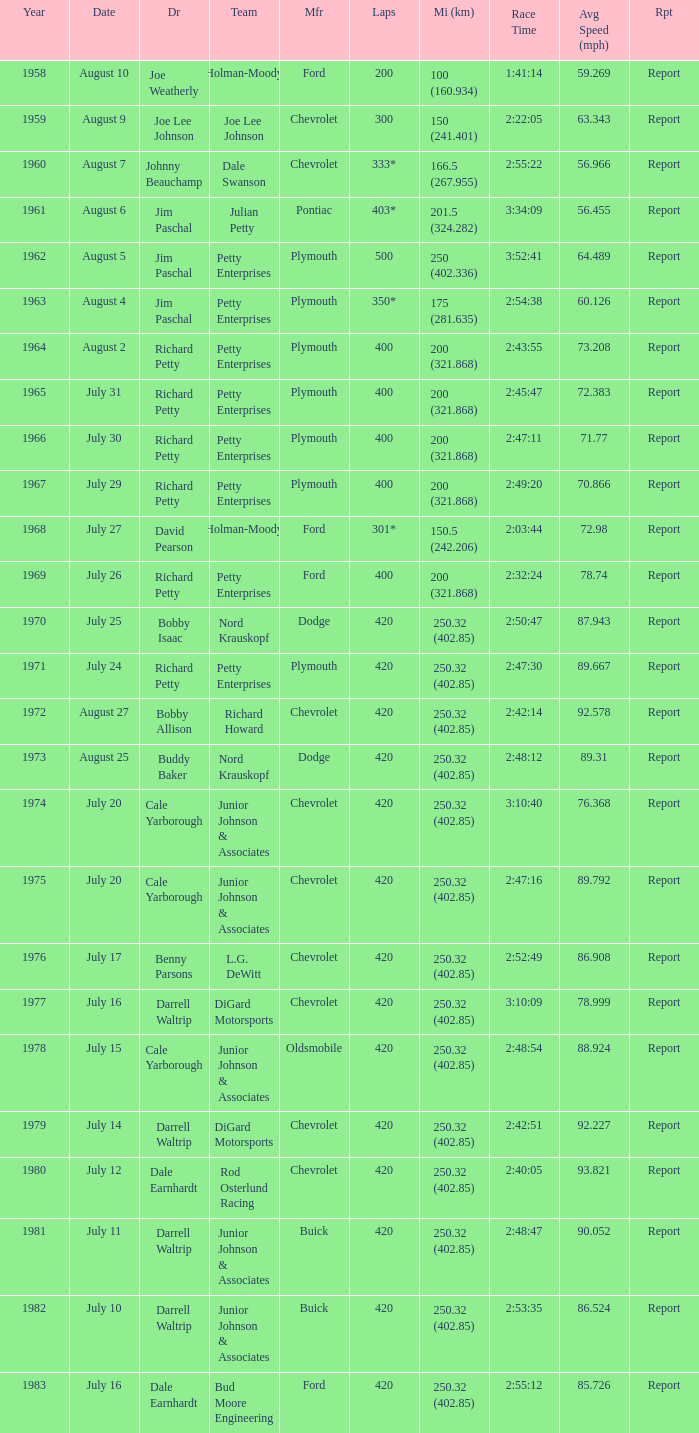What date was the race in 1968 run on? July 27. 